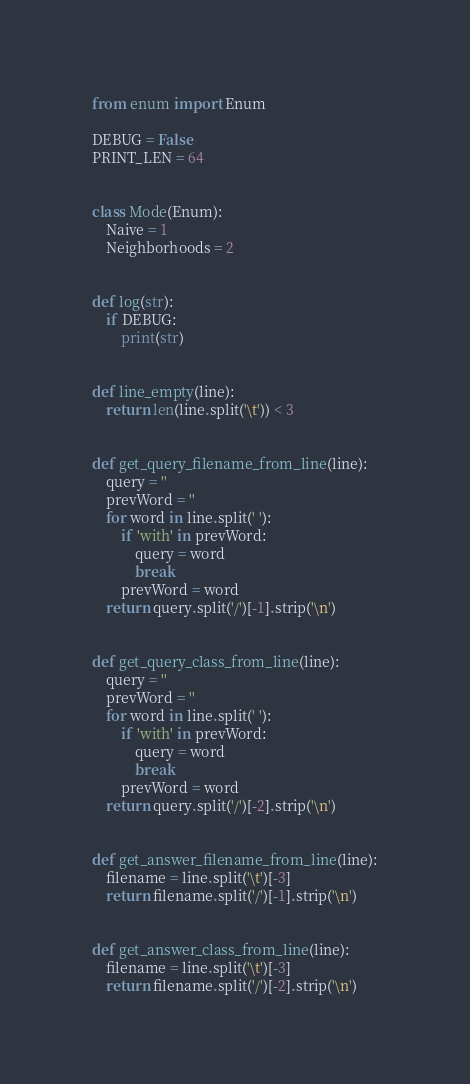<code> <loc_0><loc_0><loc_500><loc_500><_Python_>from enum import Enum

DEBUG = False
PRINT_LEN = 64


class Mode(Enum):
    Naive = 1
    Neighborhoods = 2


def log(str):
    if DEBUG:
        print(str)


def line_empty(line):
    return len(line.split('\t')) < 3


def get_query_filename_from_line(line):
    query = ''
    prevWord = ''
    for word in line.split(' '):
        if 'with' in prevWord:
            query = word
            break
        prevWord = word
    return query.split('/')[-1].strip('\n')


def get_query_class_from_line(line):
    query = ''
    prevWord = ''
    for word in line.split(' '):
        if 'with' in prevWord:
            query = word
            break
        prevWord = word
    return query.split('/')[-2].strip('\n')


def get_answer_filename_from_line(line):
    filename = line.split('\t')[-3]
    return filename.split('/')[-1].strip('\n')


def get_answer_class_from_line(line):
    filename = line.split('\t')[-3]
    return filename.split('/')[-2].strip('\n')
</code> 